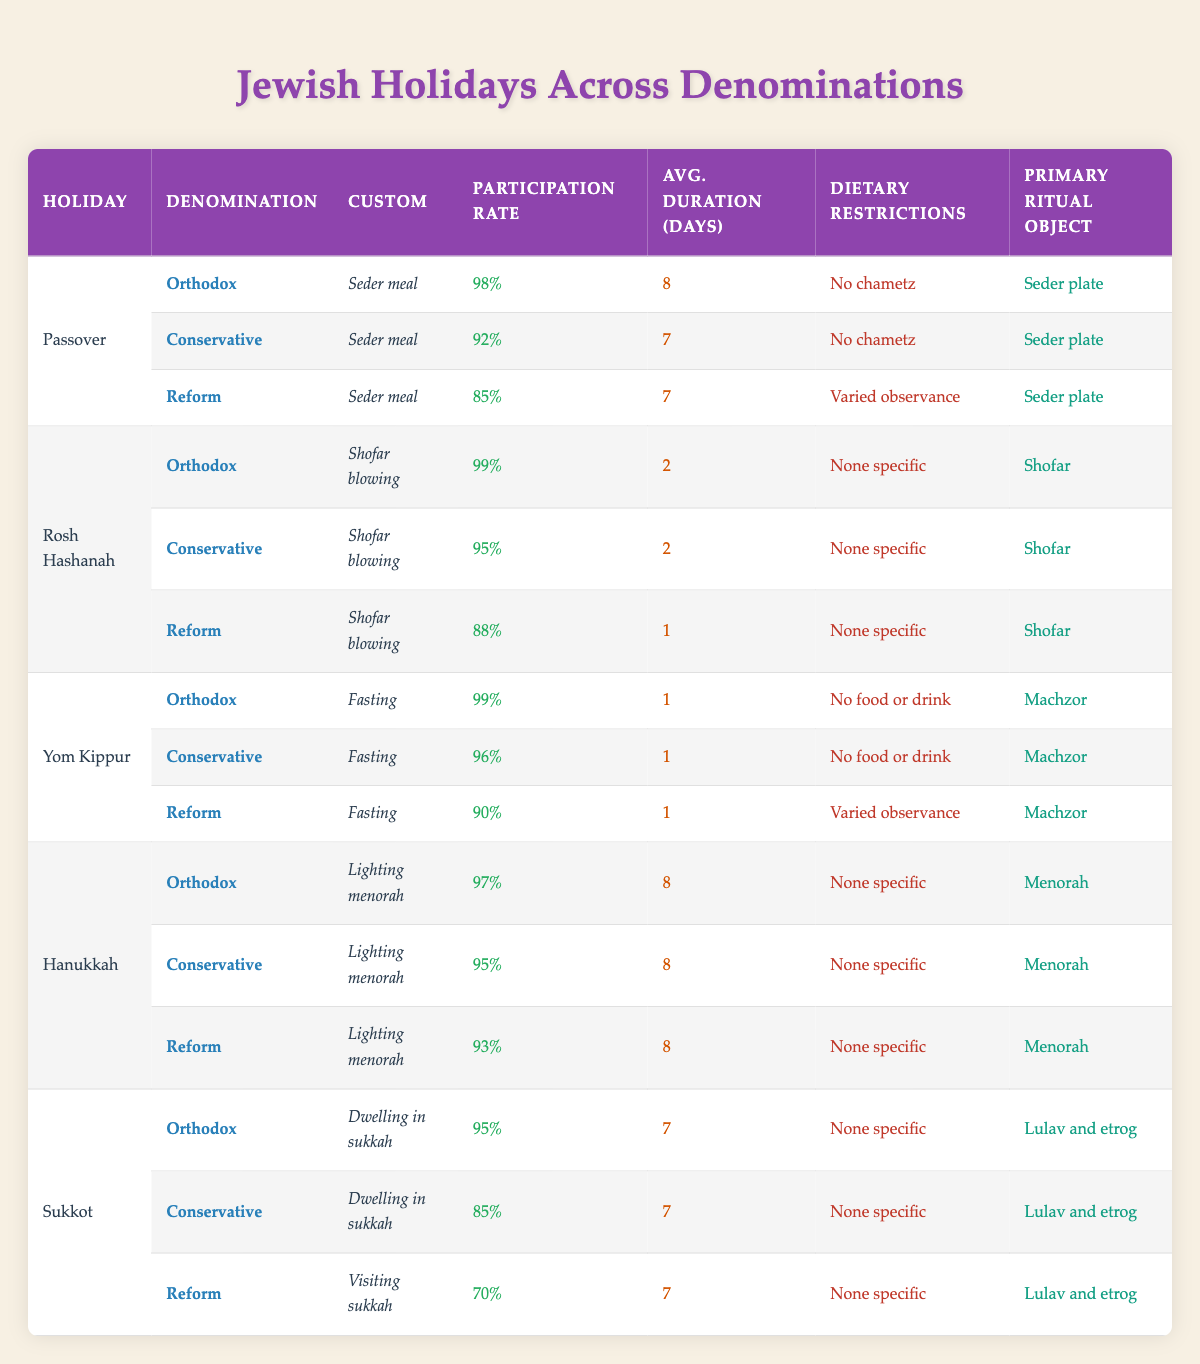What is the primary ritual object used during Yom Kippur for the Orthodox denomination? In the table, on the row corresponding to Yom Kippur for the Orthodox denomination, the primary ritual object is identified as "Machzor."
Answer: Machzor Which holiday has the highest participation rate among Conservatives? From the table, we can observe the participation rates for each holiday and denomination for Conservatives. Yom Kippur has a participation rate of 96%, which is the highest among Conservative observances.
Answer: Yom Kippur How many days is Passover observed on average among the Reform denomination? Looking at the Reform denomination's entry for Passover, it shows an average duration of 7 days.
Answer: 7 days True or False: The average participation rate for Hanukkah is higher than that for Sukkot among Orthodox Jews. The participation rates for Hanukkah (97%) and Sukkot (95%) for Orthodox Jews indicate that Hanukkah has a higher average participation rate. Thus, the statement is true.
Answer: True What is the difference in average duration of observance between Rosh Hashanah and Yom Kippur for Conservative Jews? For Conservative Jews, Rosh Hashanah's average duration is 2 days while Yom Kippur's average duration is 1 day. Therefore, the difference is calculated as 2 - 1 = 1 day.
Answer: 1 day Which holiday's custom varies among the Reform denomination regarding dietary restrictions? The table shows that for Passover, the dietary restrictions for the Reform denomination state "Varied observance," indicating that it varies from typical observance for that holiday.
Answer: Passover How many holidays have a participation rate higher than 95% for the Orthodox denomination? Observing the table, the holidays with participation rates higher than 95% for Orthodoxy are Passover (98%), Rosh Hashanah (99%), and Yom Kippur (99%). This totals three holidays.
Answer: 3 holidays What is the custom for Sukkot among the Reform denomination? By checking the table under Sukkot for Reform, it is stated that the custom is "Visiting sukkah."
Answer: Visiting sukkah What are the dietary restrictions for Hanukkah across all denominations? Analyzing the entries for Hanukkah, it shows that all denominations (Orthodox, Conservative, Reform) have "None specific" noted for dietary restrictions.
Answer: None specific 